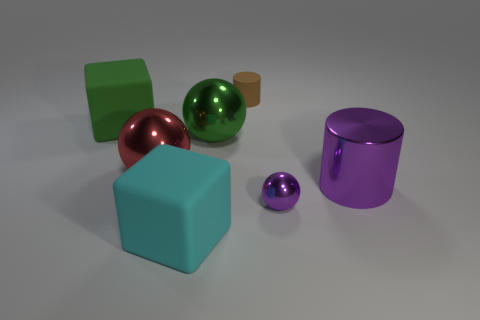There is a cylinder that is the same size as the purple sphere; what material is it?
Keep it short and to the point. Rubber. How many purple cylinders are right of the big green thing that is in front of the block that is behind the metal cylinder?
Offer a terse response. 1. Is the color of the small thing that is in front of the small brown rubber cylinder the same as the rubber cube that is on the right side of the large green matte thing?
Your answer should be compact. No. The ball that is on the right side of the large red ball and behind the purple cylinder is what color?
Offer a very short reply. Green. What number of purple things have the same size as the purple metallic cylinder?
Make the answer very short. 0. There is a green object that is on the right side of the matte cube in front of the red object; what shape is it?
Your answer should be very brief. Sphere. There is a purple metallic object behind the sphere to the right of the object that is behind the large green block; what shape is it?
Your answer should be compact. Cylinder. What number of large purple things have the same shape as the small purple metal object?
Your answer should be very brief. 0. How many large cyan matte blocks are in front of the big cube in front of the purple shiny sphere?
Provide a succinct answer. 0. What number of matte objects are purple cylinders or large spheres?
Offer a terse response. 0. 